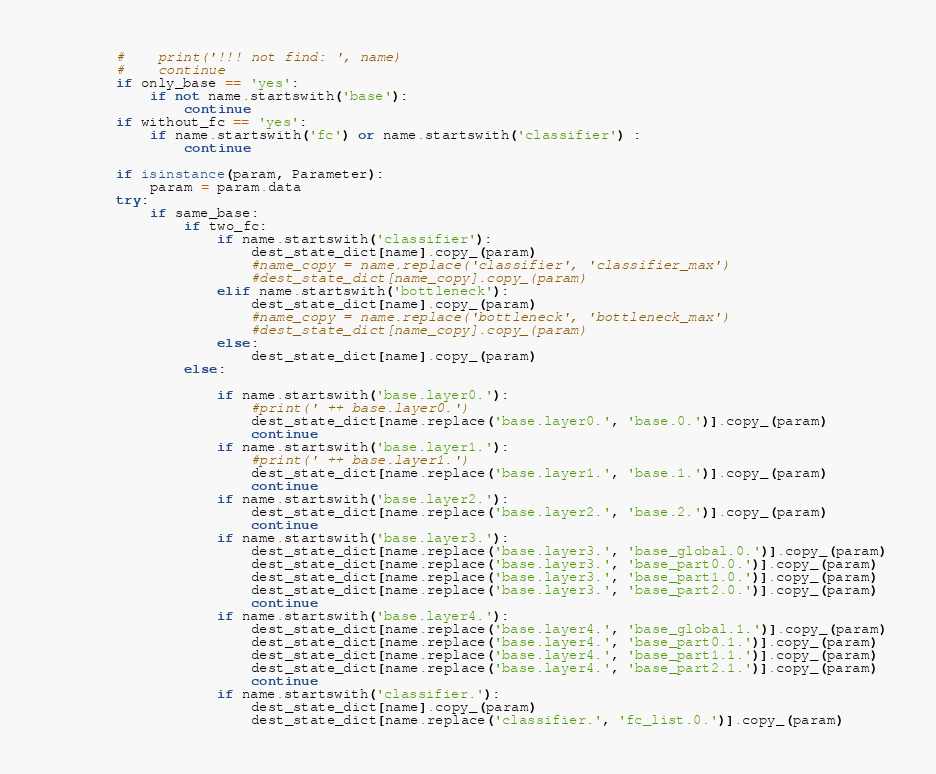<code> <loc_0><loc_0><loc_500><loc_500><_Python_>        #    print('!!! not find: ', name)
        #    continue
        if only_base == 'yes':
            if not name.startswith('base'):
                continue
        if without_fc == 'yes':
            if name.startswith('fc') or name.startswith('classifier') :
                continue

        if isinstance(param, Parameter):
            param = param.data
        try:
            if same_base:
                if two_fc:
                    if name.startswith('classifier'):
                        dest_state_dict[name].copy_(param)
                        #name_copy = name.replace('classifier', 'classifier_max')
                        #dest_state_dict[name_copy].copy_(param)
                    elif name.startswith('bottleneck'):
                        dest_state_dict[name].copy_(param)
                        #name_copy = name.replace('bottleneck', 'bottleneck_max')
                        #dest_state_dict[name_copy].copy_(param)
                    else:
                        dest_state_dict[name].copy_(param)
                else:

                    if name.startswith('base.layer0.'):
                        #print(' ++ base.layer0.')
                        dest_state_dict[name.replace('base.layer0.', 'base.0.')].copy_(param)
                        continue
                    if name.startswith('base.layer1.'):
                        #print(' ++ base.layer1.')
                        dest_state_dict[name.replace('base.layer1.', 'base.1.')].copy_(param)
                        continue
                    if name.startswith('base.layer2.'):
                        dest_state_dict[name.replace('base.layer2.', 'base.2.')].copy_(param)
                        continue
                    if name.startswith('base.layer3.'):
                        dest_state_dict[name.replace('base.layer3.', 'base_global.0.')].copy_(param)
                        dest_state_dict[name.replace('base.layer3.', 'base_part0.0.')].copy_(param)
                        dest_state_dict[name.replace('base.layer3.', 'base_part1.0.')].copy_(param)
                        dest_state_dict[name.replace('base.layer3.', 'base_part2.0.')].copy_(param)
                        continue
                    if name.startswith('base.layer4.'):
                        dest_state_dict[name.replace('base.layer4.', 'base_global.1.')].copy_(param)
                        dest_state_dict[name.replace('base.layer4.', 'base_part0.1.')].copy_(param)
                        dest_state_dict[name.replace('base.layer4.', 'base_part1.1.')].copy_(param)
                        dest_state_dict[name.replace('base.layer4.', 'base_part2.1.')].copy_(param)
                        continue
                    if name.startswith('classifier.'):
                        dest_state_dict[name].copy_(param)
                        dest_state_dict[name.replace('classifier.', 'fc_list.0.')].copy_(param)</code> 